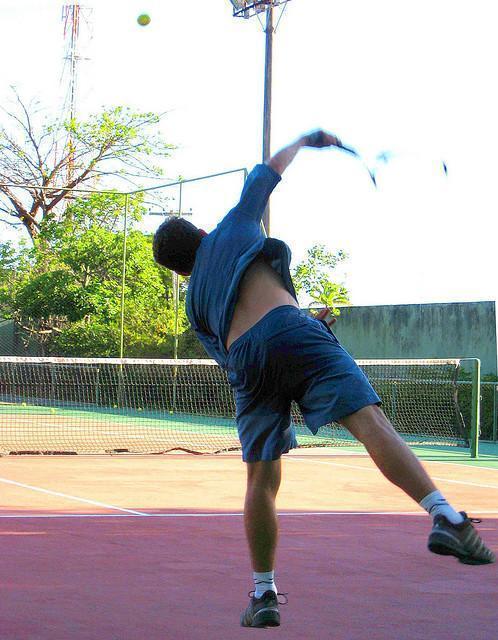What move has the player just used?
Choose the right answer from the provided options to respond to the question.
Options: Lob, backhand, forehand, serve. Serve. 